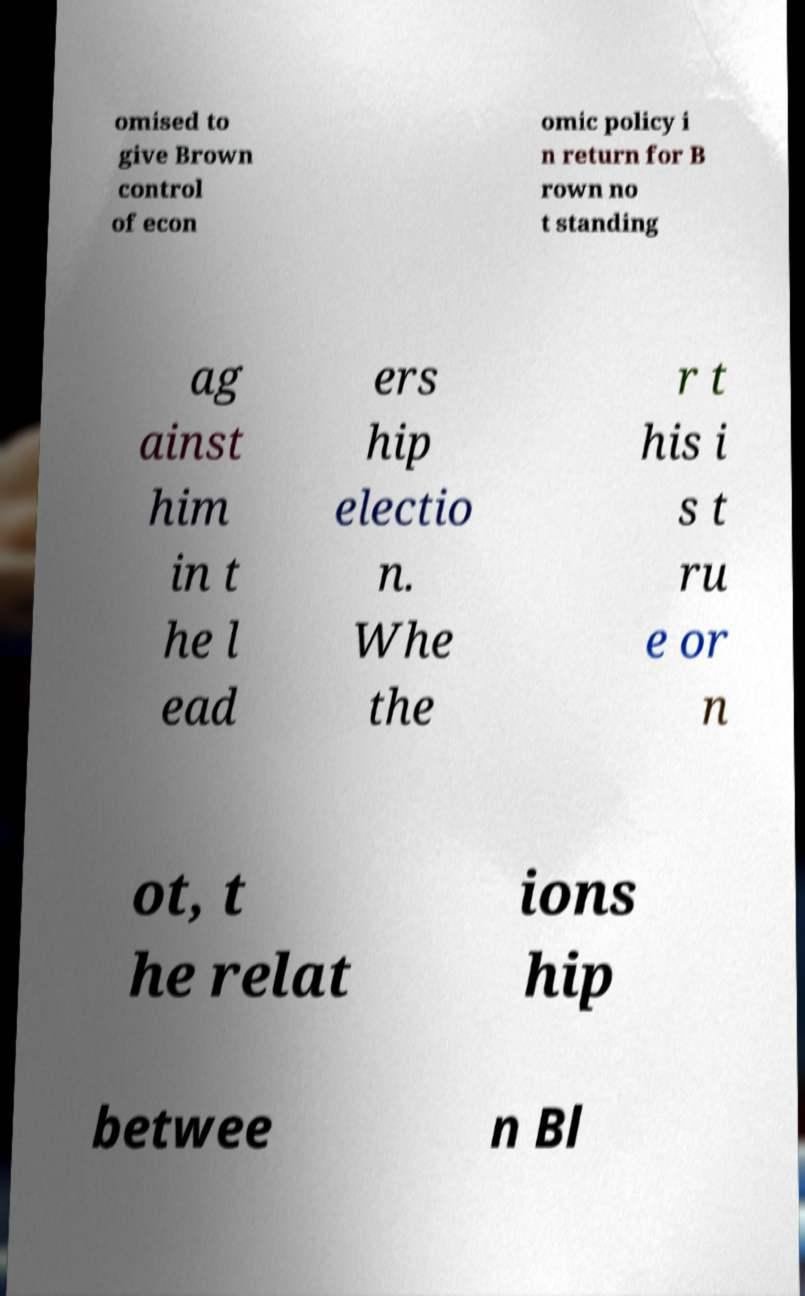Could you extract and type out the text from this image? omised to give Brown control of econ omic policy i n return for B rown no t standing ag ainst him in t he l ead ers hip electio n. Whe the r t his i s t ru e or n ot, t he relat ions hip betwee n Bl 